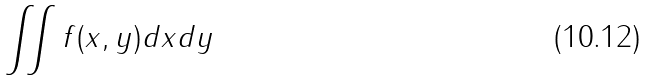<formula> <loc_0><loc_0><loc_500><loc_500>\iint f ( x , y ) d x d y</formula> 